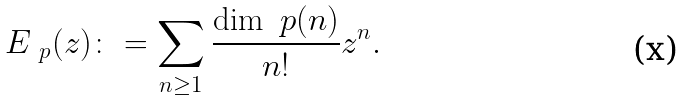<formula> <loc_0><loc_0><loc_500><loc_500>E _ { \ p } ( z ) \colon = \sum _ { n \geq 1 } \frac { \dim \ p ( n ) } { n ! } z ^ { n } .</formula> 